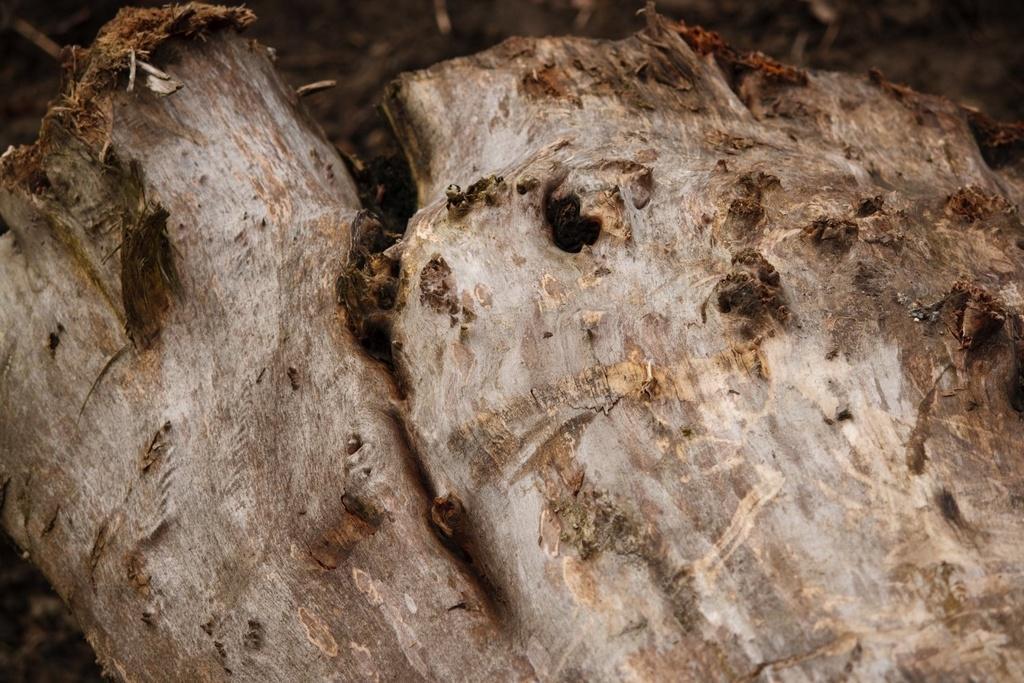Can you describe this image briefly? In this image I can see the tree trunk in brown and white color. 